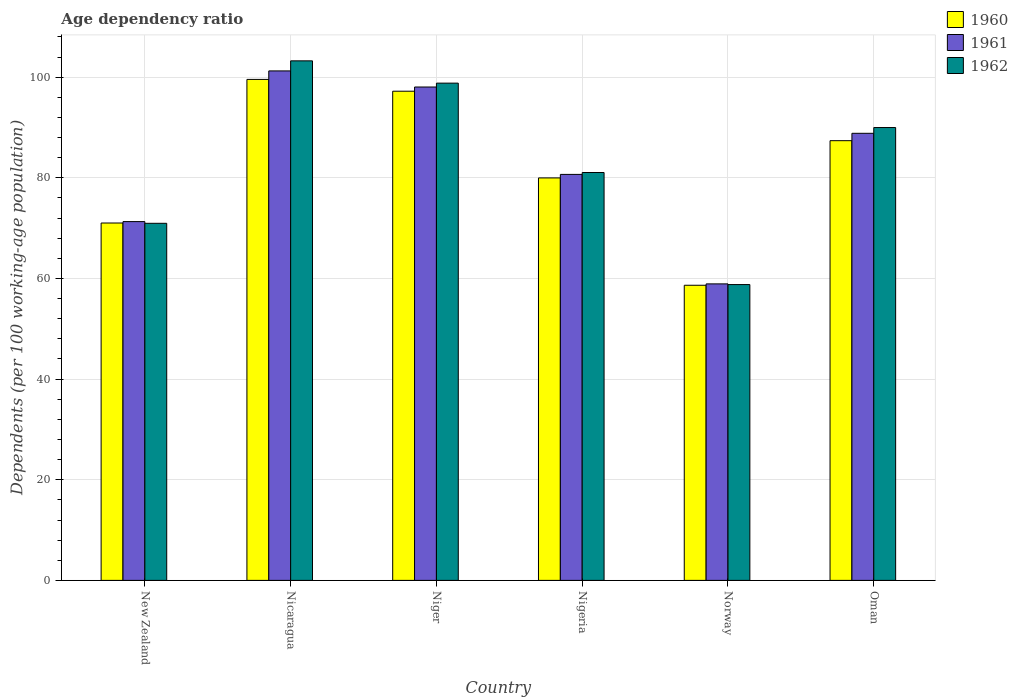How many different coloured bars are there?
Your answer should be compact. 3. How many groups of bars are there?
Provide a short and direct response. 6. Are the number of bars on each tick of the X-axis equal?
Give a very brief answer. Yes. How many bars are there on the 2nd tick from the right?
Your answer should be very brief. 3. What is the label of the 4th group of bars from the left?
Provide a short and direct response. Nigeria. What is the age dependency ratio in in 1962 in Niger?
Make the answer very short. 98.81. Across all countries, what is the maximum age dependency ratio in in 1961?
Your answer should be compact. 101.24. Across all countries, what is the minimum age dependency ratio in in 1961?
Offer a very short reply. 58.92. In which country was the age dependency ratio in in 1961 maximum?
Your answer should be very brief. Nicaragua. What is the total age dependency ratio in in 1962 in the graph?
Ensure brevity in your answer.  502.84. What is the difference between the age dependency ratio in in 1962 in New Zealand and that in Nigeria?
Your response must be concise. -10.09. What is the difference between the age dependency ratio in in 1962 in Nicaragua and the age dependency ratio in in 1960 in Nigeria?
Your answer should be compact. 23.26. What is the average age dependency ratio in in 1961 per country?
Provide a short and direct response. 83.17. What is the difference between the age dependency ratio in of/in 1961 and age dependency ratio in of/in 1960 in Nigeria?
Offer a very short reply. 0.7. What is the ratio of the age dependency ratio in in 1960 in Nicaragua to that in Oman?
Your response must be concise. 1.14. Is the age dependency ratio in in 1962 in Nicaragua less than that in Norway?
Your answer should be very brief. No. Is the difference between the age dependency ratio in in 1961 in New Zealand and Nicaragua greater than the difference between the age dependency ratio in in 1960 in New Zealand and Nicaragua?
Your response must be concise. No. What is the difference between the highest and the second highest age dependency ratio in in 1960?
Give a very brief answer. -2.34. What is the difference between the highest and the lowest age dependency ratio in in 1961?
Provide a short and direct response. 42.32. In how many countries, is the age dependency ratio in in 1960 greater than the average age dependency ratio in in 1960 taken over all countries?
Offer a terse response. 3. Is the sum of the age dependency ratio in in 1960 in New Zealand and Norway greater than the maximum age dependency ratio in in 1961 across all countries?
Make the answer very short. Yes. Is it the case that in every country, the sum of the age dependency ratio in in 1961 and age dependency ratio in in 1960 is greater than the age dependency ratio in in 1962?
Your response must be concise. Yes. How many bars are there?
Offer a terse response. 18. Are all the bars in the graph horizontal?
Ensure brevity in your answer.  No. How many countries are there in the graph?
Provide a short and direct response. 6. Are the values on the major ticks of Y-axis written in scientific E-notation?
Offer a terse response. No. Does the graph contain any zero values?
Offer a very short reply. No. Where does the legend appear in the graph?
Provide a succinct answer. Top right. What is the title of the graph?
Provide a succinct answer. Age dependency ratio. Does "2001" appear as one of the legend labels in the graph?
Ensure brevity in your answer.  No. What is the label or title of the Y-axis?
Make the answer very short. Dependents (per 100 working-age population). What is the Dependents (per 100 working-age population) of 1960 in New Zealand?
Your answer should be very brief. 71.02. What is the Dependents (per 100 working-age population) in 1961 in New Zealand?
Make the answer very short. 71.3. What is the Dependents (per 100 working-age population) of 1962 in New Zealand?
Offer a terse response. 70.96. What is the Dependents (per 100 working-age population) in 1960 in Nicaragua?
Your answer should be compact. 99.55. What is the Dependents (per 100 working-age population) in 1961 in Nicaragua?
Ensure brevity in your answer.  101.24. What is the Dependents (per 100 working-age population) in 1962 in Nicaragua?
Offer a terse response. 103.24. What is the Dependents (per 100 working-age population) in 1960 in Niger?
Offer a terse response. 97.21. What is the Dependents (per 100 working-age population) of 1961 in Niger?
Offer a very short reply. 98.04. What is the Dependents (per 100 working-age population) of 1962 in Niger?
Offer a terse response. 98.81. What is the Dependents (per 100 working-age population) in 1960 in Nigeria?
Ensure brevity in your answer.  79.98. What is the Dependents (per 100 working-age population) of 1961 in Nigeria?
Ensure brevity in your answer.  80.68. What is the Dependents (per 100 working-age population) of 1962 in Nigeria?
Give a very brief answer. 81.05. What is the Dependents (per 100 working-age population) in 1960 in Norway?
Keep it short and to the point. 58.65. What is the Dependents (per 100 working-age population) of 1961 in Norway?
Make the answer very short. 58.92. What is the Dependents (per 100 working-age population) of 1962 in Norway?
Ensure brevity in your answer.  58.78. What is the Dependents (per 100 working-age population) in 1960 in Oman?
Your response must be concise. 87.38. What is the Dependents (per 100 working-age population) in 1961 in Oman?
Give a very brief answer. 88.84. What is the Dependents (per 100 working-age population) of 1962 in Oman?
Keep it short and to the point. 89.99. Across all countries, what is the maximum Dependents (per 100 working-age population) of 1960?
Your answer should be compact. 99.55. Across all countries, what is the maximum Dependents (per 100 working-age population) in 1961?
Keep it short and to the point. 101.24. Across all countries, what is the maximum Dependents (per 100 working-age population) in 1962?
Give a very brief answer. 103.24. Across all countries, what is the minimum Dependents (per 100 working-age population) of 1960?
Give a very brief answer. 58.65. Across all countries, what is the minimum Dependents (per 100 working-age population) of 1961?
Offer a very short reply. 58.92. Across all countries, what is the minimum Dependents (per 100 working-age population) in 1962?
Provide a succinct answer. 58.78. What is the total Dependents (per 100 working-age population) of 1960 in the graph?
Your answer should be compact. 493.78. What is the total Dependents (per 100 working-age population) in 1961 in the graph?
Provide a short and direct response. 499.02. What is the total Dependents (per 100 working-age population) of 1962 in the graph?
Make the answer very short. 502.84. What is the difference between the Dependents (per 100 working-age population) in 1960 in New Zealand and that in Nicaragua?
Your answer should be very brief. -28.53. What is the difference between the Dependents (per 100 working-age population) in 1961 in New Zealand and that in Nicaragua?
Ensure brevity in your answer.  -29.95. What is the difference between the Dependents (per 100 working-age population) of 1962 in New Zealand and that in Nicaragua?
Offer a very short reply. -32.28. What is the difference between the Dependents (per 100 working-age population) of 1960 in New Zealand and that in Niger?
Keep it short and to the point. -26.19. What is the difference between the Dependents (per 100 working-age population) of 1961 in New Zealand and that in Niger?
Provide a succinct answer. -26.75. What is the difference between the Dependents (per 100 working-age population) of 1962 in New Zealand and that in Niger?
Keep it short and to the point. -27.85. What is the difference between the Dependents (per 100 working-age population) of 1960 in New Zealand and that in Nigeria?
Offer a terse response. -8.96. What is the difference between the Dependents (per 100 working-age population) of 1961 in New Zealand and that in Nigeria?
Make the answer very short. -9.38. What is the difference between the Dependents (per 100 working-age population) of 1962 in New Zealand and that in Nigeria?
Your response must be concise. -10.09. What is the difference between the Dependents (per 100 working-age population) of 1960 in New Zealand and that in Norway?
Make the answer very short. 12.37. What is the difference between the Dependents (per 100 working-age population) in 1961 in New Zealand and that in Norway?
Your answer should be compact. 12.38. What is the difference between the Dependents (per 100 working-age population) of 1962 in New Zealand and that in Norway?
Ensure brevity in your answer.  12.18. What is the difference between the Dependents (per 100 working-age population) of 1960 in New Zealand and that in Oman?
Your response must be concise. -16.36. What is the difference between the Dependents (per 100 working-age population) in 1961 in New Zealand and that in Oman?
Make the answer very short. -17.55. What is the difference between the Dependents (per 100 working-age population) in 1962 in New Zealand and that in Oman?
Keep it short and to the point. -19.03. What is the difference between the Dependents (per 100 working-age population) of 1960 in Nicaragua and that in Niger?
Make the answer very short. 2.34. What is the difference between the Dependents (per 100 working-age population) in 1961 in Nicaragua and that in Niger?
Your response must be concise. 3.2. What is the difference between the Dependents (per 100 working-age population) of 1962 in Nicaragua and that in Niger?
Keep it short and to the point. 4.43. What is the difference between the Dependents (per 100 working-age population) of 1960 in Nicaragua and that in Nigeria?
Provide a succinct answer. 19.57. What is the difference between the Dependents (per 100 working-age population) in 1961 in Nicaragua and that in Nigeria?
Offer a terse response. 20.56. What is the difference between the Dependents (per 100 working-age population) in 1962 in Nicaragua and that in Nigeria?
Provide a succinct answer. 22.19. What is the difference between the Dependents (per 100 working-age population) in 1960 in Nicaragua and that in Norway?
Ensure brevity in your answer.  40.9. What is the difference between the Dependents (per 100 working-age population) of 1961 in Nicaragua and that in Norway?
Your response must be concise. 42.32. What is the difference between the Dependents (per 100 working-age population) of 1962 in Nicaragua and that in Norway?
Ensure brevity in your answer.  44.46. What is the difference between the Dependents (per 100 working-age population) of 1960 in Nicaragua and that in Oman?
Your response must be concise. 12.17. What is the difference between the Dependents (per 100 working-age population) of 1961 in Nicaragua and that in Oman?
Make the answer very short. 12.4. What is the difference between the Dependents (per 100 working-age population) of 1962 in Nicaragua and that in Oman?
Offer a very short reply. 13.25. What is the difference between the Dependents (per 100 working-age population) of 1960 in Niger and that in Nigeria?
Offer a very short reply. 17.23. What is the difference between the Dependents (per 100 working-age population) in 1961 in Niger and that in Nigeria?
Keep it short and to the point. 17.37. What is the difference between the Dependents (per 100 working-age population) in 1962 in Niger and that in Nigeria?
Provide a short and direct response. 17.76. What is the difference between the Dependents (per 100 working-age population) in 1960 in Niger and that in Norway?
Give a very brief answer. 38.56. What is the difference between the Dependents (per 100 working-age population) of 1961 in Niger and that in Norway?
Offer a terse response. 39.13. What is the difference between the Dependents (per 100 working-age population) in 1962 in Niger and that in Norway?
Offer a terse response. 40.03. What is the difference between the Dependents (per 100 working-age population) of 1960 in Niger and that in Oman?
Your answer should be compact. 9.83. What is the difference between the Dependents (per 100 working-age population) in 1961 in Niger and that in Oman?
Ensure brevity in your answer.  9.2. What is the difference between the Dependents (per 100 working-age population) in 1962 in Niger and that in Oman?
Offer a terse response. 8.82. What is the difference between the Dependents (per 100 working-age population) in 1960 in Nigeria and that in Norway?
Make the answer very short. 21.33. What is the difference between the Dependents (per 100 working-age population) of 1961 in Nigeria and that in Norway?
Offer a terse response. 21.76. What is the difference between the Dependents (per 100 working-age population) of 1962 in Nigeria and that in Norway?
Your response must be concise. 22.27. What is the difference between the Dependents (per 100 working-age population) in 1960 in Nigeria and that in Oman?
Provide a succinct answer. -7.4. What is the difference between the Dependents (per 100 working-age population) in 1961 in Nigeria and that in Oman?
Keep it short and to the point. -8.17. What is the difference between the Dependents (per 100 working-age population) in 1962 in Nigeria and that in Oman?
Provide a succinct answer. -8.94. What is the difference between the Dependents (per 100 working-age population) in 1960 in Norway and that in Oman?
Give a very brief answer. -28.73. What is the difference between the Dependents (per 100 working-age population) of 1961 in Norway and that in Oman?
Provide a succinct answer. -29.92. What is the difference between the Dependents (per 100 working-age population) of 1962 in Norway and that in Oman?
Your answer should be compact. -31.21. What is the difference between the Dependents (per 100 working-age population) in 1960 in New Zealand and the Dependents (per 100 working-age population) in 1961 in Nicaragua?
Provide a short and direct response. -30.23. What is the difference between the Dependents (per 100 working-age population) in 1960 in New Zealand and the Dependents (per 100 working-age population) in 1962 in Nicaragua?
Your answer should be compact. -32.22. What is the difference between the Dependents (per 100 working-age population) in 1961 in New Zealand and the Dependents (per 100 working-age population) in 1962 in Nicaragua?
Provide a short and direct response. -31.94. What is the difference between the Dependents (per 100 working-age population) of 1960 in New Zealand and the Dependents (per 100 working-age population) of 1961 in Niger?
Ensure brevity in your answer.  -27.03. What is the difference between the Dependents (per 100 working-age population) in 1960 in New Zealand and the Dependents (per 100 working-age population) in 1962 in Niger?
Your answer should be compact. -27.8. What is the difference between the Dependents (per 100 working-age population) in 1961 in New Zealand and the Dependents (per 100 working-age population) in 1962 in Niger?
Your answer should be compact. -27.52. What is the difference between the Dependents (per 100 working-age population) in 1960 in New Zealand and the Dependents (per 100 working-age population) in 1961 in Nigeria?
Your answer should be very brief. -9.66. What is the difference between the Dependents (per 100 working-age population) in 1960 in New Zealand and the Dependents (per 100 working-age population) in 1962 in Nigeria?
Give a very brief answer. -10.04. What is the difference between the Dependents (per 100 working-age population) of 1961 in New Zealand and the Dependents (per 100 working-age population) of 1962 in Nigeria?
Provide a short and direct response. -9.76. What is the difference between the Dependents (per 100 working-age population) of 1960 in New Zealand and the Dependents (per 100 working-age population) of 1961 in Norway?
Give a very brief answer. 12.1. What is the difference between the Dependents (per 100 working-age population) in 1960 in New Zealand and the Dependents (per 100 working-age population) in 1962 in Norway?
Offer a terse response. 12.23. What is the difference between the Dependents (per 100 working-age population) in 1961 in New Zealand and the Dependents (per 100 working-age population) in 1962 in Norway?
Keep it short and to the point. 12.51. What is the difference between the Dependents (per 100 working-age population) of 1960 in New Zealand and the Dependents (per 100 working-age population) of 1961 in Oman?
Your answer should be very brief. -17.83. What is the difference between the Dependents (per 100 working-age population) in 1960 in New Zealand and the Dependents (per 100 working-age population) in 1962 in Oman?
Offer a very short reply. -18.97. What is the difference between the Dependents (per 100 working-age population) of 1961 in New Zealand and the Dependents (per 100 working-age population) of 1962 in Oman?
Offer a very short reply. -18.69. What is the difference between the Dependents (per 100 working-age population) of 1960 in Nicaragua and the Dependents (per 100 working-age population) of 1961 in Niger?
Provide a succinct answer. 1.51. What is the difference between the Dependents (per 100 working-age population) in 1960 in Nicaragua and the Dependents (per 100 working-age population) in 1962 in Niger?
Provide a succinct answer. 0.74. What is the difference between the Dependents (per 100 working-age population) of 1961 in Nicaragua and the Dependents (per 100 working-age population) of 1962 in Niger?
Your answer should be compact. 2.43. What is the difference between the Dependents (per 100 working-age population) in 1960 in Nicaragua and the Dependents (per 100 working-age population) in 1961 in Nigeria?
Offer a terse response. 18.87. What is the difference between the Dependents (per 100 working-age population) in 1960 in Nicaragua and the Dependents (per 100 working-age population) in 1962 in Nigeria?
Keep it short and to the point. 18.5. What is the difference between the Dependents (per 100 working-age population) in 1961 in Nicaragua and the Dependents (per 100 working-age population) in 1962 in Nigeria?
Provide a short and direct response. 20.19. What is the difference between the Dependents (per 100 working-age population) in 1960 in Nicaragua and the Dependents (per 100 working-age population) in 1961 in Norway?
Your answer should be compact. 40.63. What is the difference between the Dependents (per 100 working-age population) in 1960 in Nicaragua and the Dependents (per 100 working-age population) in 1962 in Norway?
Your response must be concise. 40.77. What is the difference between the Dependents (per 100 working-age population) in 1961 in Nicaragua and the Dependents (per 100 working-age population) in 1962 in Norway?
Your answer should be very brief. 42.46. What is the difference between the Dependents (per 100 working-age population) of 1960 in Nicaragua and the Dependents (per 100 working-age population) of 1961 in Oman?
Your response must be concise. 10.71. What is the difference between the Dependents (per 100 working-age population) of 1960 in Nicaragua and the Dependents (per 100 working-age population) of 1962 in Oman?
Make the answer very short. 9.56. What is the difference between the Dependents (per 100 working-age population) in 1961 in Nicaragua and the Dependents (per 100 working-age population) in 1962 in Oman?
Make the answer very short. 11.25. What is the difference between the Dependents (per 100 working-age population) of 1960 in Niger and the Dependents (per 100 working-age population) of 1961 in Nigeria?
Offer a very short reply. 16.53. What is the difference between the Dependents (per 100 working-age population) of 1960 in Niger and the Dependents (per 100 working-age population) of 1962 in Nigeria?
Your answer should be very brief. 16.16. What is the difference between the Dependents (per 100 working-age population) in 1961 in Niger and the Dependents (per 100 working-age population) in 1962 in Nigeria?
Keep it short and to the point. 16.99. What is the difference between the Dependents (per 100 working-age population) of 1960 in Niger and the Dependents (per 100 working-age population) of 1961 in Norway?
Ensure brevity in your answer.  38.29. What is the difference between the Dependents (per 100 working-age population) of 1960 in Niger and the Dependents (per 100 working-age population) of 1962 in Norway?
Keep it short and to the point. 38.42. What is the difference between the Dependents (per 100 working-age population) in 1961 in Niger and the Dependents (per 100 working-age population) in 1962 in Norway?
Make the answer very short. 39.26. What is the difference between the Dependents (per 100 working-age population) of 1960 in Niger and the Dependents (per 100 working-age population) of 1961 in Oman?
Offer a terse response. 8.36. What is the difference between the Dependents (per 100 working-age population) in 1960 in Niger and the Dependents (per 100 working-age population) in 1962 in Oman?
Make the answer very short. 7.22. What is the difference between the Dependents (per 100 working-age population) in 1961 in Niger and the Dependents (per 100 working-age population) in 1962 in Oman?
Give a very brief answer. 8.05. What is the difference between the Dependents (per 100 working-age population) of 1960 in Nigeria and the Dependents (per 100 working-age population) of 1961 in Norway?
Your answer should be very brief. 21.06. What is the difference between the Dependents (per 100 working-age population) of 1960 in Nigeria and the Dependents (per 100 working-age population) of 1962 in Norway?
Offer a very short reply. 21.2. What is the difference between the Dependents (per 100 working-age population) in 1961 in Nigeria and the Dependents (per 100 working-age population) in 1962 in Norway?
Your answer should be compact. 21.89. What is the difference between the Dependents (per 100 working-age population) in 1960 in Nigeria and the Dependents (per 100 working-age population) in 1961 in Oman?
Ensure brevity in your answer.  -8.86. What is the difference between the Dependents (per 100 working-age population) in 1960 in Nigeria and the Dependents (per 100 working-age population) in 1962 in Oman?
Keep it short and to the point. -10.01. What is the difference between the Dependents (per 100 working-age population) in 1961 in Nigeria and the Dependents (per 100 working-age population) in 1962 in Oman?
Your answer should be compact. -9.31. What is the difference between the Dependents (per 100 working-age population) in 1960 in Norway and the Dependents (per 100 working-age population) in 1961 in Oman?
Make the answer very short. -30.2. What is the difference between the Dependents (per 100 working-age population) in 1960 in Norway and the Dependents (per 100 working-age population) in 1962 in Oman?
Provide a succinct answer. -31.34. What is the difference between the Dependents (per 100 working-age population) in 1961 in Norway and the Dependents (per 100 working-age population) in 1962 in Oman?
Offer a terse response. -31.07. What is the average Dependents (per 100 working-age population) in 1960 per country?
Make the answer very short. 82.3. What is the average Dependents (per 100 working-age population) in 1961 per country?
Offer a terse response. 83.17. What is the average Dependents (per 100 working-age population) in 1962 per country?
Provide a succinct answer. 83.81. What is the difference between the Dependents (per 100 working-age population) in 1960 and Dependents (per 100 working-age population) in 1961 in New Zealand?
Offer a very short reply. -0.28. What is the difference between the Dependents (per 100 working-age population) of 1960 and Dependents (per 100 working-age population) of 1962 in New Zealand?
Provide a succinct answer. 0.06. What is the difference between the Dependents (per 100 working-age population) of 1961 and Dependents (per 100 working-age population) of 1962 in New Zealand?
Provide a succinct answer. 0.34. What is the difference between the Dependents (per 100 working-age population) of 1960 and Dependents (per 100 working-age population) of 1961 in Nicaragua?
Your response must be concise. -1.69. What is the difference between the Dependents (per 100 working-age population) of 1960 and Dependents (per 100 working-age population) of 1962 in Nicaragua?
Your answer should be compact. -3.69. What is the difference between the Dependents (per 100 working-age population) of 1961 and Dependents (per 100 working-age population) of 1962 in Nicaragua?
Your answer should be very brief. -2. What is the difference between the Dependents (per 100 working-age population) in 1960 and Dependents (per 100 working-age population) in 1961 in Niger?
Provide a succinct answer. -0.84. What is the difference between the Dependents (per 100 working-age population) in 1960 and Dependents (per 100 working-age population) in 1962 in Niger?
Offer a terse response. -1.61. What is the difference between the Dependents (per 100 working-age population) of 1961 and Dependents (per 100 working-age population) of 1962 in Niger?
Your answer should be compact. -0.77. What is the difference between the Dependents (per 100 working-age population) of 1960 and Dependents (per 100 working-age population) of 1961 in Nigeria?
Provide a succinct answer. -0.7. What is the difference between the Dependents (per 100 working-age population) of 1960 and Dependents (per 100 working-age population) of 1962 in Nigeria?
Provide a short and direct response. -1.07. What is the difference between the Dependents (per 100 working-age population) of 1961 and Dependents (per 100 working-age population) of 1962 in Nigeria?
Keep it short and to the point. -0.37. What is the difference between the Dependents (per 100 working-age population) in 1960 and Dependents (per 100 working-age population) in 1961 in Norway?
Your answer should be compact. -0.27. What is the difference between the Dependents (per 100 working-age population) of 1960 and Dependents (per 100 working-age population) of 1962 in Norway?
Make the answer very short. -0.14. What is the difference between the Dependents (per 100 working-age population) in 1961 and Dependents (per 100 working-age population) in 1962 in Norway?
Offer a very short reply. 0.14. What is the difference between the Dependents (per 100 working-age population) of 1960 and Dependents (per 100 working-age population) of 1961 in Oman?
Your answer should be compact. -1.47. What is the difference between the Dependents (per 100 working-age population) of 1960 and Dependents (per 100 working-age population) of 1962 in Oman?
Ensure brevity in your answer.  -2.61. What is the difference between the Dependents (per 100 working-age population) of 1961 and Dependents (per 100 working-age population) of 1962 in Oman?
Your answer should be compact. -1.15. What is the ratio of the Dependents (per 100 working-age population) in 1960 in New Zealand to that in Nicaragua?
Give a very brief answer. 0.71. What is the ratio of the Dependents (per 100 working-age population) in 1961 in New Zealand to that in Nicaragua?
Give a very brief answer. 0.7. What is the ratio of the Dependents (per 100 working-age population) in 1962 in New Zealand to that in Nicaragua?
Offer a terse response. 0.69. What is the ratio of the Dependents (per 100 working-age population) of 1960 in New Zealand to that in Niger?
Offer a very short reply. 0.73. What is the ratio of the Dependents (per 100 working-age population) in 1961 in New Zealand to that in Niger?
Give a very brief answer. 0.73. What is the ratio of the Dependents (per 100 working-age population) of 1962 in New Zealand to that in Niger?
Your answer should be very brief. 0.72. What is the ratio of the Dependents (per 100 working-age population) of 1960 in New Zealand to that in Nigeria?
Your answer should be very brief. 0.89. What is the ratio of the Dependents (per 100 working-age population) in 1961 in New Zealand to that in Nigeria?
Ensure brevity in your answer.  0.88. What is the ratio of the Dependents (per 100 working-age population) of 1962 in New Zealand to that in Nigeria?
Give a very brief answer. 0.88. What is the ratio of the Dependents (per 100 working-age population) in 1960 in New Zealand to that in Norway?
Your response must be concise. 1.21. What is the ratio of the Dependents (per 100 working-age population) in 1961 in New Zealand to that in Norway?
Provide a succinct answer. 1.21. What is the ratio of the Dependents (per 100 working-age population) in 1962 in New Zealand to that in Norway?
Provide a succinct answer. 1.21. What is the ratio of the Dependents (per 100 working-age population) in 1960 in New Zealand to that in Oman?
Your answer should be very brief. 0.81. What is the ratio of the Dependents (per 100 working-age population) in 1961 in New Zealand to that in Oman?
Provide a short and direct response. 0.8. What is the ratio of the Dependents (per 100 working-age population) of 1962 in New Zealand to that in Oman?
Give a very brief answer. 0.79. What is the ratio of the Dependents (per 100 working-age population) in 1960 in Nicaragua to that in Niger?
Provide a short and direct response. 1.02. What is the ratio of the Dependents (per 100 working-age population) of 1961 in Nicaragua to that in Niger?
Provide a short and direct response. 1.03. What is the ratio of the Dependents (per 100 working-age population) in 1962 in Nicaragua to that in Niger?
Your answer should be very brief. 1.04. What is the ratio of the Dependents (per 100 working-age population) in 1960 in Nicaragua to that in Nigeria?
Your response must be concise. 1.24. What is the ratio of the Dependents (per 100 working-age population) of 1961 in Nicaragua to that in Nigeria?
Give a very brief answer. 1.25. What is the ratio of the Dependents (per 100 working-age population) in 1962 in Nicaragua to that in Nigeria?
Provide a succinct answer. 1.27. What is the ratio of the Dependents (per 100 working-age population) of 1960 in Nicaragua to that in Norway?
Make the answer very short. 1.7. What is the ratio of the Dependents (per 100 working-age population) in 1961 in Nicaragua to that in Norway?
Your response must be concise. 1.72. What is the ratio of the Dependents (per 100 working-age population) in 1962 in Nicaragua to that in Norway?
Offer a very short reply. 1.76. What is the ratio of the Dependents (per 100 working-age population) in 1960 in Nicaragua to that in Oman?
Your answer should be very brief. 1.14. What is the ratio of the Dependents (per 100 working-age population) in 1961 in Nicaragua to that in Oman?
Your response must be concise. 1.14. What is the ratio of the Dependents (per 100 working-age population) in 1962 in Nicaragua to that in Oman?
Provide a short and direct response. 1.15. What is the ratio of the Dependents (per 100 working-age population) in 1960 in Niger to that in Nigeria?
Your answer should be compact. 1.22. What is the ratio of the Dependents (per 100 working-age population) of 1961 in Niger to that in Nigeria?
Give a very brief answer. 1.22. What is the ratio of the Dependents (per 100 working-age population) in 1962 in Niger to that in Nigeria?
Keep it short and to the point. 1.22. What is the ratio of the Dependents (per 100 working-age population) in 1960 in Niger to that in Norway?
Provide a short and direct response. 1.66. What is the ratio of the Dependents (per 100 working-age population) of 1961 in Niger to that in Norway?
Make the answer very short. 1.66. What is the ratio of the Dependents (per 100 working-age population) of 1962 in Niger to that in Norway?
Ensure brevity in your answer.  1.68. What is the ratio of the Dependents (per 100 working-age population) of 1960 in Niger to that in Oman?
Offer a terse response. 1.11. What is the ratio of the Dependents (per 100 working-age population) of 1961 in Niger to that in Oman?
Provide a succinct answer. 1.1. What is the ratio of the Dependents (per 100 working-age population) in 1962 in Niger to that in Oman?
Your answer should be compact. 1.1. What is the ratio of the Dependents (per 100 working-age population) in 1960 in Nigeria to that in Norway?
Offer a terse response. 1.36. What is the ratio of the Dependents (per 100 working-age population) of 1961 in Nigeria to that in Norway?
Provide a succinct answer. 1.37. What is the ratio of the Dependents (per 100 working-age population) in 1962 in Nigeria to that in Norway?
Give a very brief answer. 1.38. What is the ratio of the Dependents (per 100 working-age population) of 1960 in Nigeria to that in Oman?
Provide a succinct answer. 0.92. What is the ratio of the Dependents (per 100 working-age population) in 1961 in Nigeria to that in Oman?
Offer a very short reply. 0.91. What is the ratio of the Dependents (per 100 working-age population) of 1962 in Nigeria to that in Oman?
Your answer should be very brief. 0.9. What is the ratio of the Dependents (per 100 working-age population) in 1960 in Norway to that in Oman?
Provide a succinct answer. 0.67. What is the ratio of the Dependents (per 100 working-age population) of 1961 in Norway to that in Oman?
Your answer should be compact. 0.66. What is the ratio of the Dependents (per 100 working-age population) of 1962 in Norway to that in Oman?
Give a very brief answer. 0.65. What is the difference between the highest and the second highest Dependents (per 100 working-age population) of 1960?
Make the answer very short. 2.34. What is the difference between the highest and the second highest Dependents (per 100 working-age population) of 1961?
Offer a very short reply. 3.2. What is the difference between the highest and the second highest Dependents (per 100 working-age population) of 1962?
Provide a succinct answer. 4.43. What is the difference between the highest and the lowest Dependents (per 100 working-age population) in 1960?
Offer a very short reply. 40.9. What is the difference between the highest and the lowest Dependents (per 100 working-age population) in 1961?
Your answer should be compact. 42.32. What is the difference between the highest and the lowest Dependents (per 100 working-age population) of 1962?
Offer a very short reply. 44.46. 